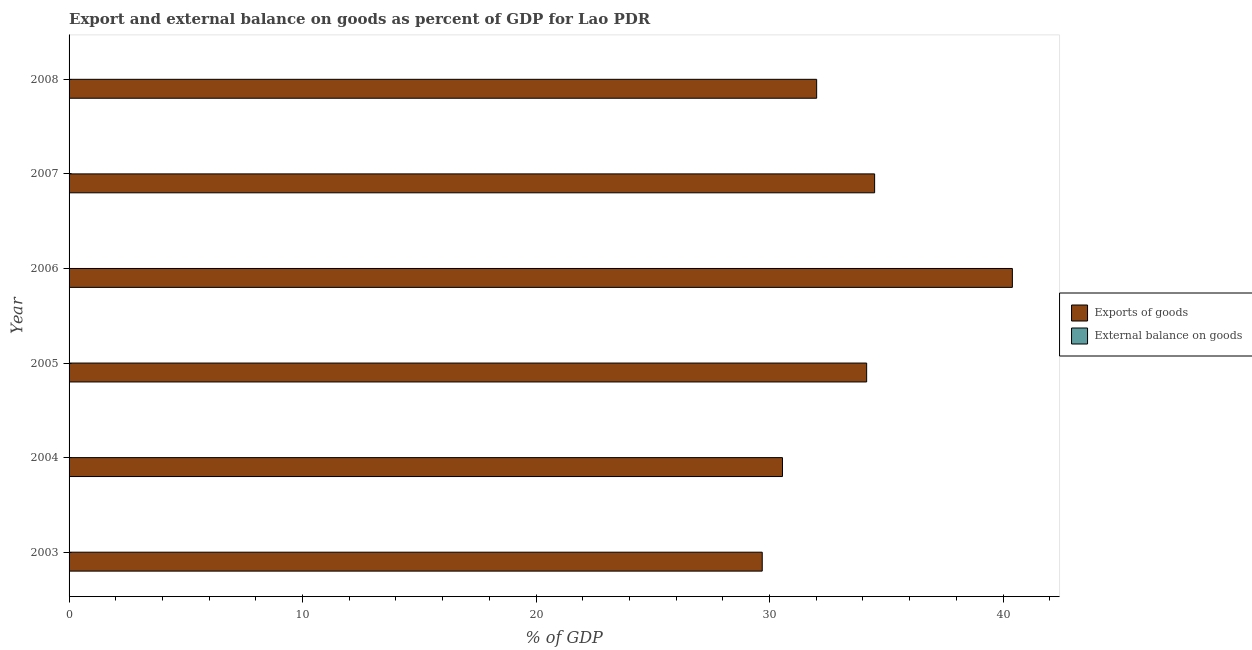How many different coloured bars are there?
Provide a short and direct response. 1. Are the number of bars per tick equal to the number of legend labels?
Your response must be concise. No. How many bars are there on the 4th tick from the bottom?
Your answer should be compact. 1. In how many cases, is the number of bars for a given year not equal to the number of legend labels?
Offer a very short reply. 6. Across all years, what is the maximum export of goods as percentage of gdp?
Make the answer very short. 40.4. Across all years, what is the minimum export of goods as percentage of gdp?
Give a very brief answer. 29.69. In which year was the export of goods as percentage of gdp maximum?
Your response must be concise. 2006. What is the total export of goods as percentage of gdp in the graph?
Give a very brief answer. 201.31. What is the difference between the export of goods as percentage of gdp in 2005 and that in 2006?
Make the answer very short. -6.24. What is the difference between the external balance on goods as percentage of gdp in 2006 and the export of goods as percentage of gdp in 2003?
Provide a succinct answer. -29.69. What is the average export of goods as percentage of gdp per year?
Give a very brief answer. 33.55. In how many years, is the export of goods as percentage of gdp greater than 2 %?
Your response must be concise. 6. Is the export of goods as percentage of gdp in 2003 less than that in 2004?
Keep it short and to the point. Yes. What is the difference between the highest and the second highest export of goods as percentage of gdp?
Ensure brevity in your answer.  5.9. What is the difference between the highest and the lowest export of goods as percentage of gdp?
Keep it short and to the point. 10.71. In how many years, is the external balance on goods as percentage of gdp greater than the average external balance on goods as percentage of gdp taken over all years?
Your response must be concise. 0. Is the sum of the export of goods as percentage of gdp in 2004 and 2005 greater than the maximum external balance on goods as percentage of gdp across all years?
Offer a very short reply. Yes. How many years are there in the graph?
Offer a very short reply. 6. Does the graph contain any zero values?
Your answer should be very brief. Yes. Does the graph contain grids?
Keep it short and to the point. No. What is the title of the graph?
Offer a terse response. Export and external balance on goods as percent of GDP for Lao PDR. Does "Agricultural land" appear as one of the legend labels in the graph?
Make the answer very short. No. What is the label or title of the X-axis?
Provide a succinct answer. % of GDP. What is the label or title of the Y-axis?
Give a very brief answer. Year. What is the % of GDP of Exports of goods in 2003?
Your answer should be compact. 29.69. What is the % of GDP of Exports of goods in 2004?
Offer a terse response. 30.55. What is the % of GDP in External balance on goods in 2004?
Your answer should be compact. 0. What is the % of GDP of Exports of goods in 2005?
Your response must be concise. 34.16. What is the % of GDP of External balance on goods in 2005?
Provide a succinct answer. 0. What is the % of GDP of Exports of goods in 2006?
Your answer should be compact. 40.4. What is the % of GDP of Exports of goods in 2007?
Keep it short and to the point. 34.5. What is the % of GDP of Exports of goods in 2008?
Make the answer very short. 32.02. What is the % of GDP in External balance on goods in 2008?
Provide a succinct answer. 0. Across all years, what is the maximum % of GDP in Exports of goods?
Your response must be concise. 40.4. Across all years, what is the minimum % of GDP in Exports of goods?
Offer a terse response. 29.69. What is the total % of GDP in Exports of goods in the graph?
Make the answer very short. 201.31. What is the total % of GDP in External balance on goods in the graph?
Give a very brief answer. 0. What is the difference between the % of GDP in Exports of goods in 2003 and that in 2004?
Offer a terse response. -0.87. What is the difference between the % of GDP of Exports of goods in 2003 and that in 2005?
Your answer should be very brief. -4.47. What is the difference between the % of GDP in Exports of goods in 2003 and that in 2006?
Offer a terse response. -10.71. What is the difference between the % of GDP of Exports of goods in 2003 and that in 2007?
Your response must be concise. -4.81. What is the difference between the % of GDP of Exports of goods in 2003 and that in 2008?
Ensure brevity in your answer.  -2.33. What is the difference between the % of GDP of Exports of goods in 2004 and that in 2005?
Make the answer very short. -3.6. What is the difference between the % of GDP in Exports of goods in 2004 and that in 2006?
Give a very brief answer. -9.85. What is the difference between the % of GDP in Exports of goods in 2004 and that in 2007?
Ensure brevity in your answer.  -3.95. What is the difference between the % of GDP in Exports of goods in 2004 and that in 2008?
Offer a terse response. -1.46. What is the difference between the % of GDP in Exports of goods in 2005 and that in 2006?
Offer a terse response. -6.24. What is the difference between the % of GDP of Exports of goods in 2005 and that in 2007?
Make the answer very short. -0.34. What is the difference between the % of GDP of Exports of goods in 2005 and that in 2008?
Ensure brevity in your answer.  2.14. What is the difference between the % of GDP in Exports of goods in 2006 and that in 2007?
Offer a very short reply. 5.9. What is the difference between the % of GDP of Exports of goods in 2006 and that in 2008?
Ensure brevity in your answer.  8.38. What is the difference between the % of GDP in Exports of goods in 2007 and that in 2008?
Provide a succinct answer. 2.48. What is the average % of GDP of Exports of goods per year?
Your answer should be very brief. 33.55. What is the ratio of the % of GDP in Exports of goods in 2003 to that in 2004?
Provide a succinct answer. 0.97. What is the ratio of the % of GDP of Exports of goods in 2003 to that in 2005?
Provide a short and direct response. 0.87. What is the ratio of the % of GDP in Exports of goods in 2003 to that in 2006?
Your answer should be very brief. 0.73. What is the ratio of the % of GDP in Exports of goods in 2003 to that in 2007?
Provide a short and direct response. 0.86. What is the ratio of the % of GDP in Exports of goods in 2003 to that in 2008?
Offer a very short reply. 0.93. What is the ratio of the % of GDP of Exports of goods in 2004 to that in 2005?
Your answer should be very brief. 0.89. What is the ratio of the % of GDP of Exports of goods in 2004 to that in 2006?
Offer a terse response. 0.76. What is the ratio of the % of GDP in Exports of goods in 2004 to that in 2007?
Your answer should be compact. 0.89. What is the ratio of the % of GDP in Exports of goods in 2004 to that in 2008?
Offer a very short reply. 0.95. What is the ratio of the % of GDP of Exports of goods in 2005 to that in 2006?
Ensure brevity in your answer.  0.85. What is the ratio of the % of GDP in Exports of goods in 2005 to that in 2007?
Give a very brief answer. 0.99. What is the ratio of the % of GDP of Exports of goods in 2005 to that in 2008?
Offer a very short reply. 1.07. What is the ratio of the % of GDP in Exports of goods in 2006 to that in 2007?
Ensure brevity in your answer.  1.17. What is the ratio of the % of GDP in Exports of goods in 2006 to that in 2008?
Keep it short and to the point. 1.26. What is the ratio of the % of GDP in Exports of goods in 2007 to that in 2008?
Provide a succinct answer. 1.08. What is the difference between the highest and the second highest % of GDP of Exports of goods?
Give a very brief answer. 5.9. What is the difference between the highest and the lowest % of GDP of Exports of goods?
Your response must be concise. 10.71. 